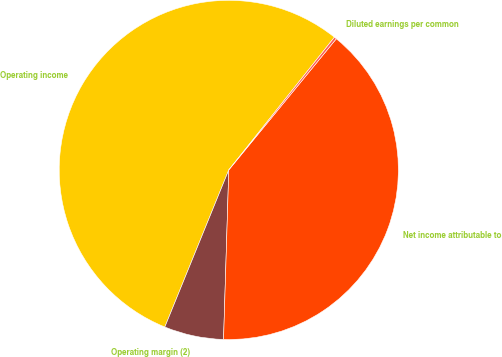Convert chart. <chart><loc_0><loc_0><loc_500><loc_500><pie_chart><fcel>Operating income<fcel>Operating margin (2)<fcel>Net income attributable to<fcel>Diluted earnings per common<nl><fcel>54.54%<fcel>5.66%<fcel>39.56%<fcel>0.23%<nl></chart> 